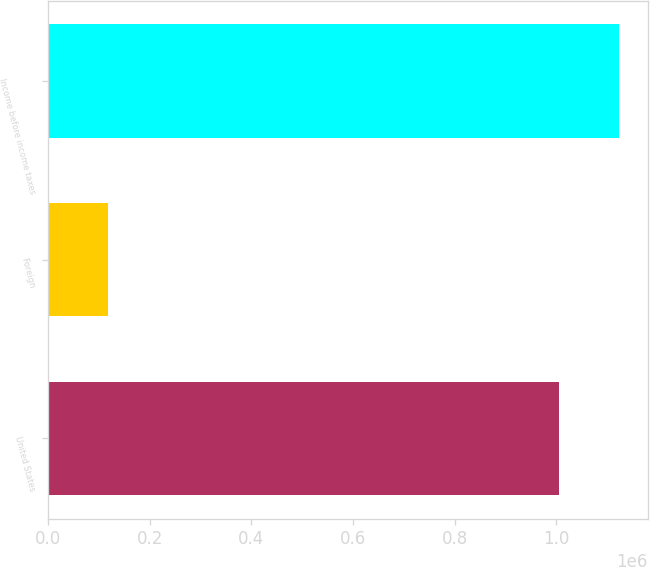Convert chart to OTSL. <chart><loc_0><loc_0><loc_500><loc_500><bar_chart><fcel>United States<fcel>Foreign<fcel>Income before income taxes<nl><fcel>1.00492e+06<fcel>118762<fcel>1.12368e+06<nl></chart> 